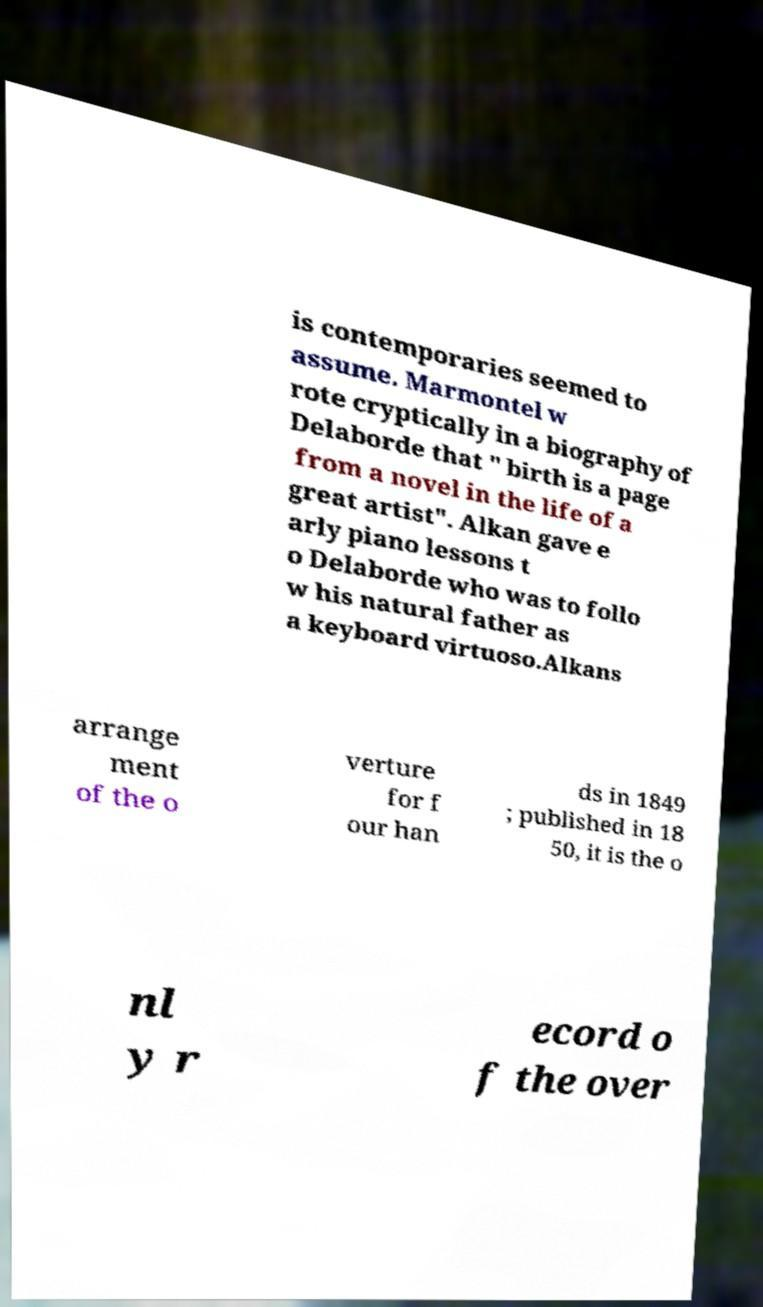For documentation purposes, I need the text within this image transcribed. Could you provide that? is contemporaries seemed to assume. Marmontel w rote cryptically in a biography of Delaborde that " birth is a page from a novel in the life of a great artist". Alkan gave e arly piano lessons t o Delaborde who was to follo w his natural father as a keyboard virtuoso.Alkans arrange ment of the o verture for f our han ds in 1849 ; published in 18 50, it is the o nl y r ecord o f the over 